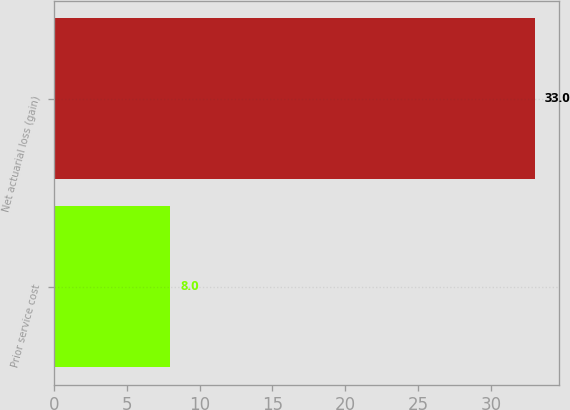Convert chart to OTSL. <chart><loc_0><loc_0><loc_500><loc_500><bar_chart><fcel>Prior service cost<fcel>Net actuarial loss (gain)<nl><fcel>8<fcel>33<nl></chart> 